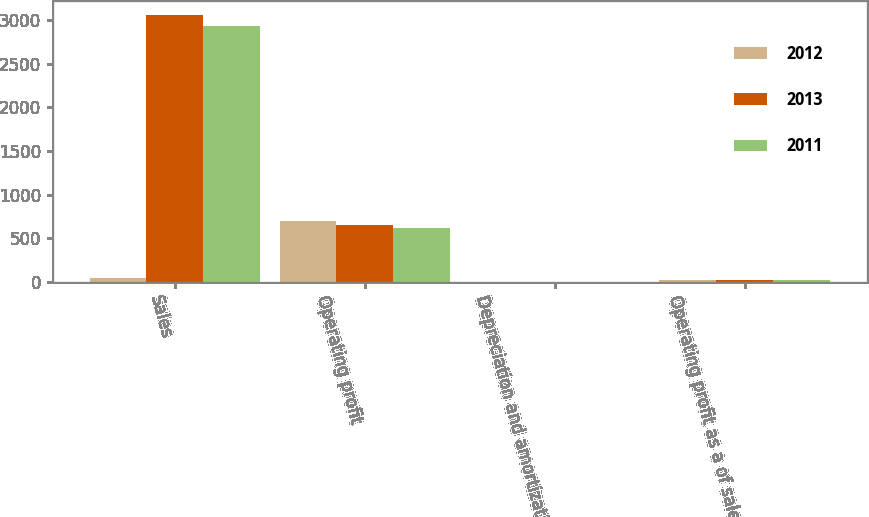Convert chart. <chart><loc_0><loc_0><loc_500><loc_500><stacked_bar_chart><ecel><fcel>Sales<fcel>Operating profit<fcel>Depreciation and amortization<fcel>Operating profit as a of sales<nl><fcel>2012<fcel>47.4<fcel>696.5<fcel>1.9<fcel>21<nl><fcel>2013<fcel>3063.5<fcel>652.5<fcel>1.6<fcel>21.3<nl><fcel>2011<fcel>2939.6<fcel>622.7<fcel>1.6<fcel>21.2<nl></chart> 